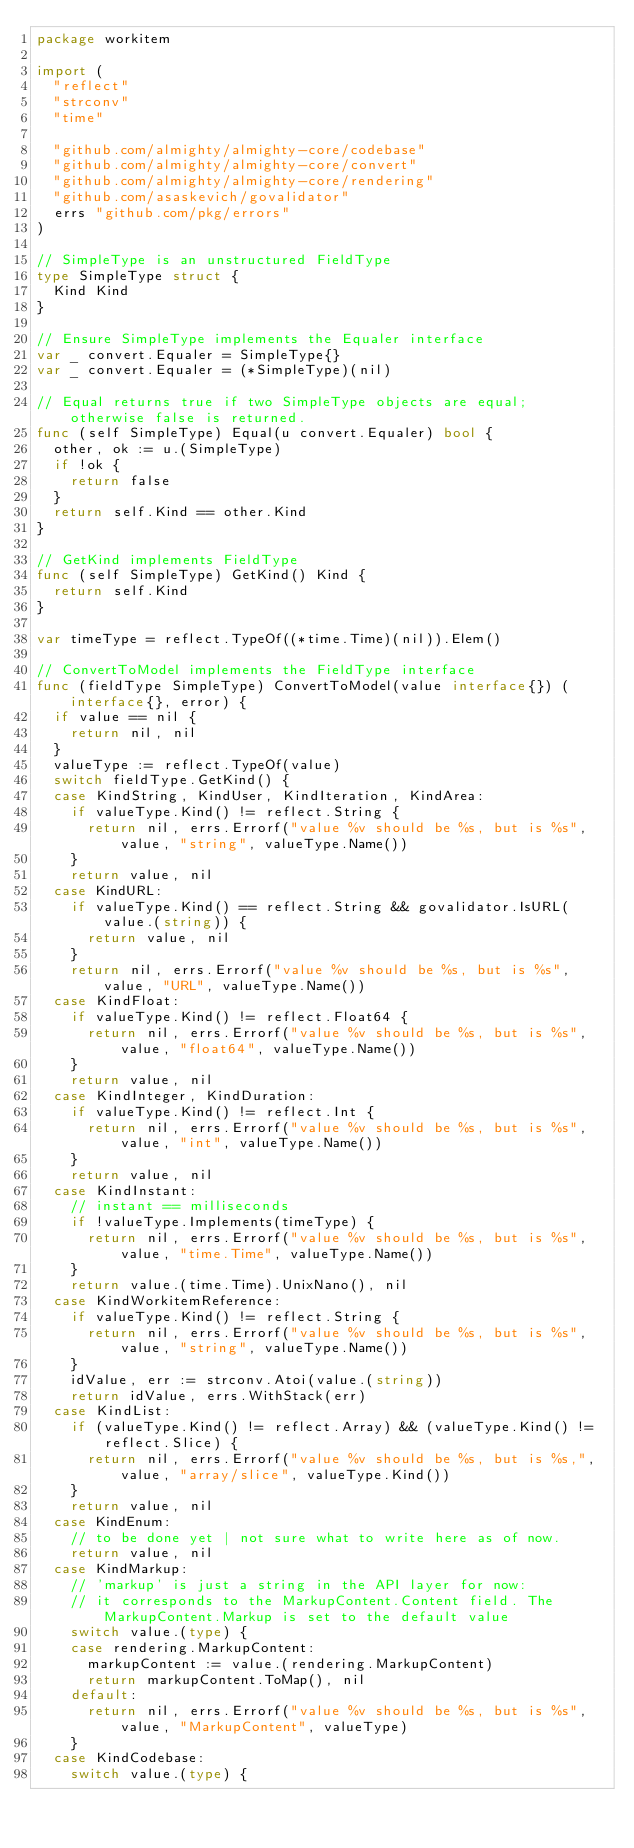<code> <loc_0><loc_0><loc_500><loc_500><_Go_>package workitem

import (
	"reflect"
	"strconv"
	"time"

	"github.com/almighty/almighty-core/codebase"
	"github.com/almighty/almighty-core/convert"
	"github.com/almighty/almighty-core/rendering"
	"github.com/asaskevich/govalidator"
	errs "github.com/pkg/errors"
)

// SimpleType is an unstructured FieldType
type SimpleType struct {
	Kind Kind
}

// Ensure SimpleType implements the Equaler interface
var _ convert.Equaler = SimpleType{}
var _ convert.Equaler = (*SimpleType)(nil)

// Equal returns true if two SimpleType objects are equal; otherwise false is returned.
func (self SimpleType) Equal(u convert.Equaler) bool {
	other, ok := u.(SimpleType)
	if !ok {
		return false
	}
	return self.Kind == other.Kind
}

// GetKind implements FieldType
func (self SimpleType) GetKind() Kind {
	return self.Kind
}

var timeType = reflect.TypeOf((*time.Time)(nil)).Elem()

// ConvertToModel implements the FieldType interface
func (fieldType SimpleType) ConvertToModel(value interface{}) (interface{}, error) {
	if value == nil {
		return nil, nil
	}
	valueType := reflect.TypeOf(value)
	switch fieldType.GetKind() {
	case KindString, KindUser, KindIteration, KindArea:
		if valueType.Kind() != reflect.String {
			return nil, errs.Errorf("value %v should be %s, but is %s", value, "string", valueType.Name())
		}
		return value, nil
	case KindURL:
		if valueType.Kind() == reflect.String && govalidator.IsURL(value.(string)) {
			return value, nil
		}
		return nil, errs.Errorf("value %v should be %s, but is %s", value, "URL", valueType.Name())
	case KindFloat:
		if valueType.Kind() != reflect.Float64 {
			return nil, errs.Errorf("value %v should be %s, but is %s", value, "float64", valueType.Name())
		}
		return value, nil
	case KindInteger, KindDuration:
		if valueType.Kind() != reflect.Int {
			return nil, errs.Errorf("value %v should be %s, but is %s", value, "int", valueType.Name())
		}
		return value, nil
	case KindInstant:
		// instant == milliseconds
		if !valueType.Implements(timeType) {
			return nil, errs.Errorf("value %v should be %s, but is %s", value, "time.Time", valueType.Name())
		}
		return value.(time.Time).UnixNano(), nil
	case KindWorkitemReference:
		if valueType.Kind() != reflect.String {
			return nil, errs.Errorf("value %v should be %s, but is %s", value, "string", valueType.Name())
		}
		idValue, err := strconv.Atoi(value.(string))
		return idValue, errs.WithStack(err)
	case KindList:
		if (valueType.Kind() != reflect.Array) && (valueType.Kind() != reflect.Slice) {
			return nil, errs.Errorf("value %v should be %s, but is %s,", value, "array/slice", valueType.Kind())
		}
		return value, nil
	case KindEnum:
		// to be done yet | not sure what to write here as of now.
		return value, nil
	case KindMarkup:
		// 'markup' is just a string in the API layer for now:
		// it corresponds to the MarkupContent.Content field. The MarkupContent.Markup is set to the default value
		switch value.(type) {
		case rendering.MarkupContent:
			markupContent := value.(rendering.MarkupContent)
			return markupContent.ToMap(), nil
		default:
			return nil, errs.Errorf("value %v should be %s, but is %s", value, "MarkupContent", valueType)
		}
	case KindCodebase:
		switch value.(type) {</code> 